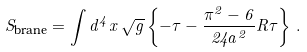<formula> <loc_0><loc_0><loc_500><loc_500>S _ { \text {brane} } = \int d ^ { 4 } x \, \sqrt { g } \left \{ - \tau - \frac { \pi ^ { 2 } - 6 } { 2 4 a ^ { 2 } } R \tau \right \} \, .</formula> 